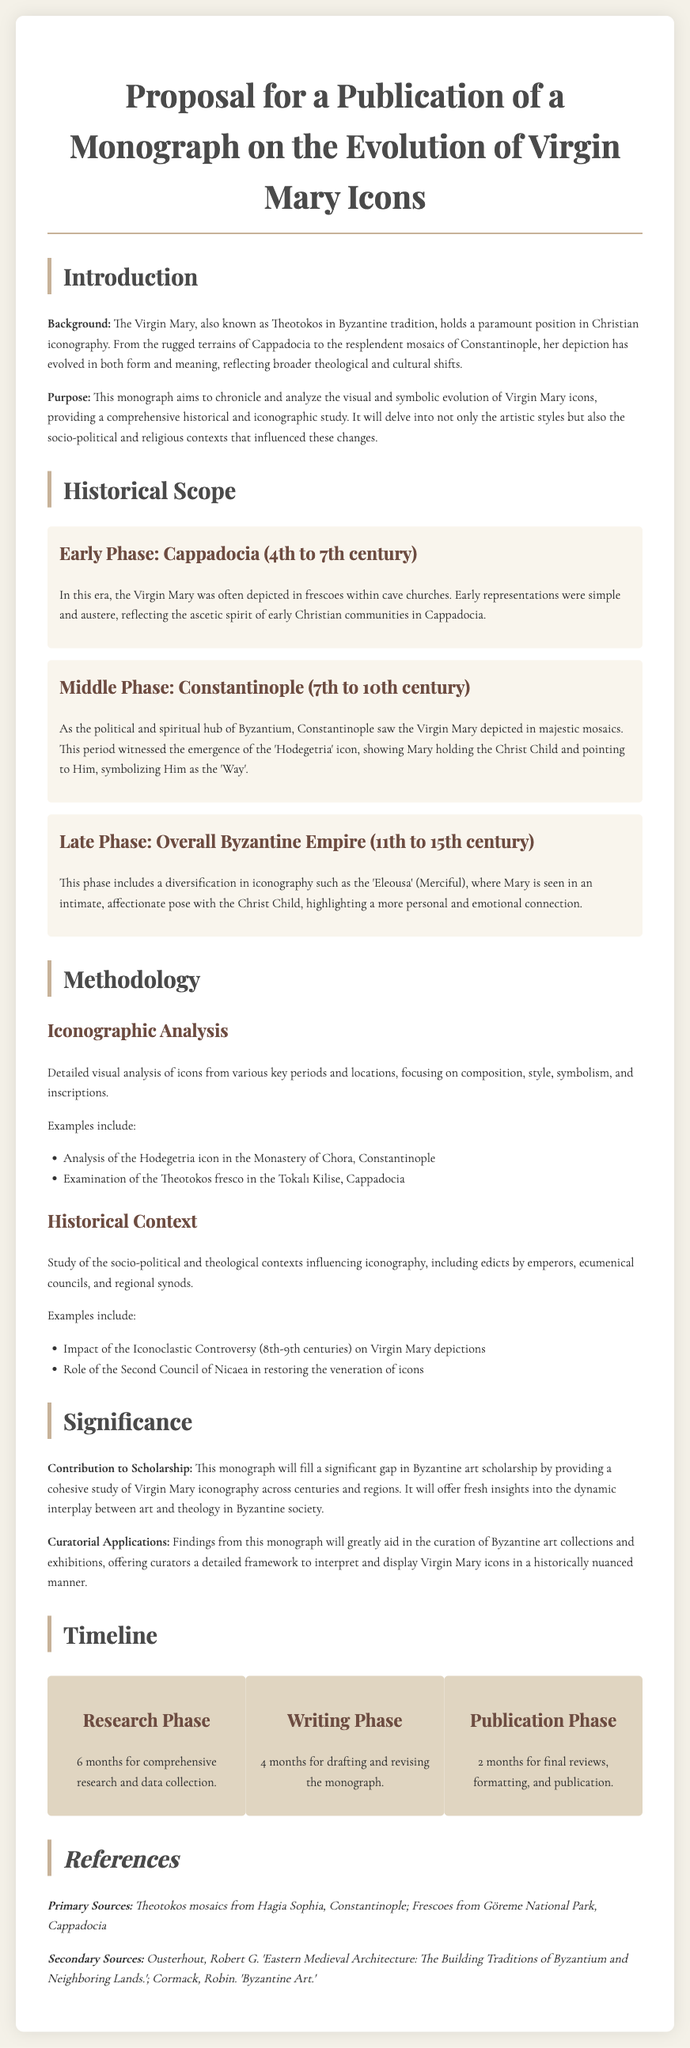what is the title of the monograph? The title of the monograph is clearly stated at the beginning of the proposal.
Answer: Evolution of Virgin Mary Icons what is the historical scope of the early phase? The early phase is summarized in the document, specifying the geographical and temporal context.
Answer: Cappadocia (4th to 7th century) how long is the research phase? The duration for the research phase is mentioned in the timeline section of the proposal.
Answer: 6 months which icon is analyzed in the Monastery of Chora? The document specifies which icon is the focus of the analysis within the context of iconographic studies.
Answer: Hodegetria icon what significant event impacted Virgin Mary depictions? The impact of this specific historical event is discussed in the methodology section of the proposal.
Answer: Iconoclastic Controversy what is the purpose of the monograph? The document directly articulates the goal of the monograph in the introduction.
Answer: To chronicle and analyze the visual and symbolic evolution how many months are allocated for the writing phase? The timeline section details the length of this specific phase in the publication process.
Answer: 4 months what style will the monograph contribute to scholarship? The significance section indicates the type of contribution the monograph aims to make.
Answer: A cohesive study which primary sources are referenced? Specific primary sources are listed in the references section of the proposal.
Answer: Theotokos mosaics from Hagia Sophia, Constantinople what will the findings aid in? The curatorial applications section specifies what the findings from the monograph will support.
Answer: Curation of Byzantine art collections 